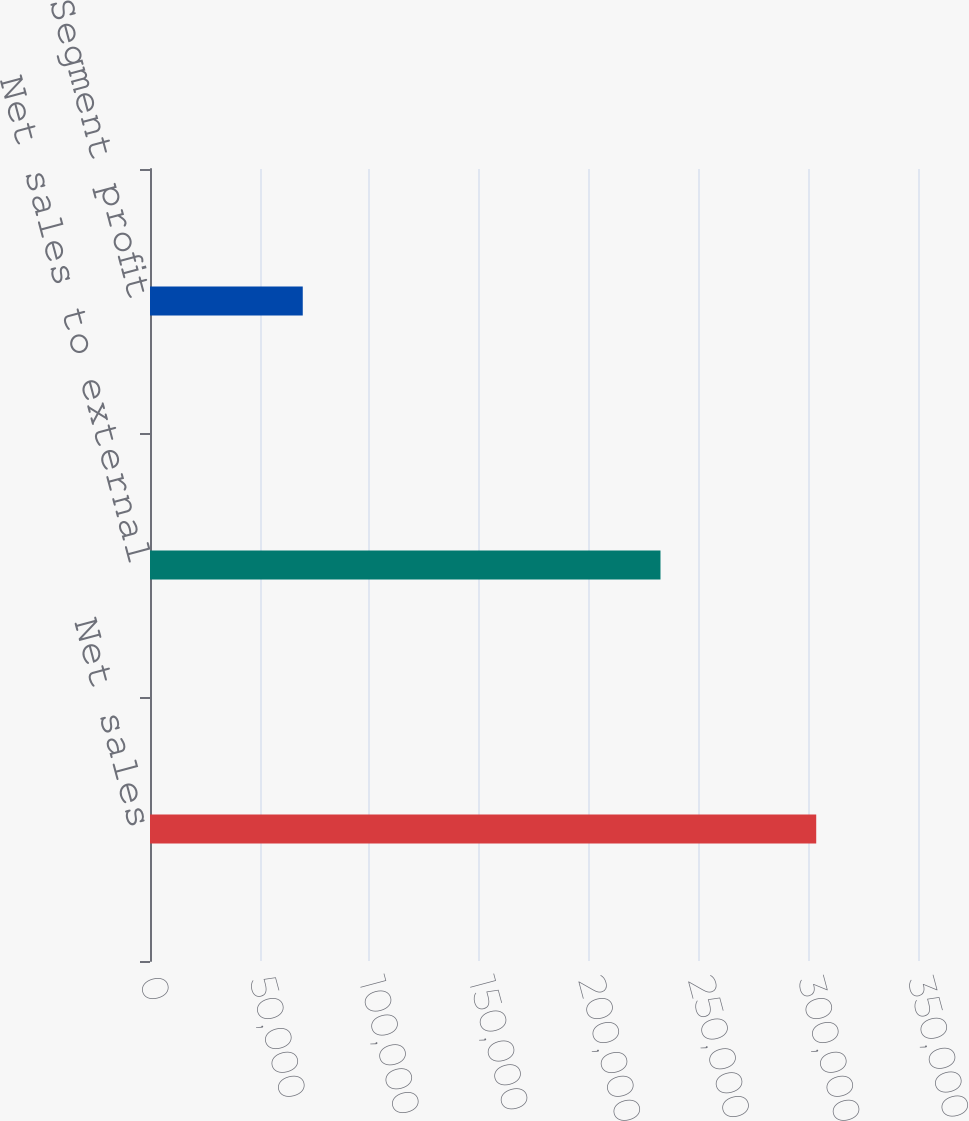<chart> <loc_0><loc_0><loc_500><loc_500><bar_chart><fcel>Net sales<fcel>Net sales to external<fcel>Segment profit<nl><fcel>303614<fcel>232643<fcel>69617<nl></chart> 